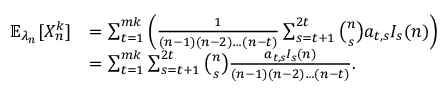<formula> <loc_0><loc_0><loc_500><loc_500>\begin{array} { r l } { \mathbb { E } _ { \lambda _ { n } } [ X _ { n } ^ { k } ] } & { = \sum _ { t = 1 } ^ { m k } \left ( \frac { 1 } { ( n - 1 ) ( n - 2 ) \dots ( n - t ) } \sum _ { s = t + 1 } ^ { 2 t } { \binom { n } { s } } a _ { t , s } I _ { s } ( n ) \right ) } \\ & { = \sum _ { t = 1 } ^ { m k } \sum _ { s = t + 1 } ^ { 2 t } { \binom { n } { s } } \frac { a _ { t , s } I _ { s } ( n ) } { ( n - 1 ) ( n - 2 ) \dots ( n - t ) } . } \end{array}</formula> 